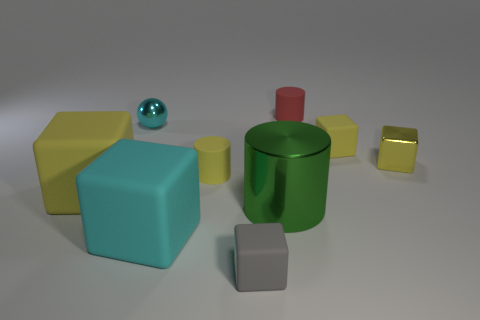The rubber thing that is the same color as the sphere is what shape?
Provide a succinct answer. Cube. Are there any tiny things of the same color as the tiny metal ball?
Make the answer very short. No. Are there the same number of rubber cylinders that are in front of the big green cylinder and green shiny cylinders right of the red cylinder?
Your answer should be very brief. Yes. There is a green shiny object; is its shape the same as the big matte thing that is in front of the green object?
Your answer should be very brief. No. What number of other things are there of the same material as the large cyan thing
Offer a very short reply. 5. There is a big green metallic cylinder; are there any red things in front of it?
Ensure brevity in your answer.  No. Is the size of the gray block the same as the yellow matte thing behind the yellow matte cylinder?
Your answer should be compact. Yes. What is the color of the matte cylinder that is right of the cylinder that is to the left of the tiny gray matte block?
Offer a very short reply. Red. Do the green metallic object and the cyan rubber object have the same size?
Your response must be concise. Yes. What is the color of the tiny thing that is left of the large shiny cylinder and on the right side of the small yellow matte cylinder?
Keep it short and to the point. Gray. 